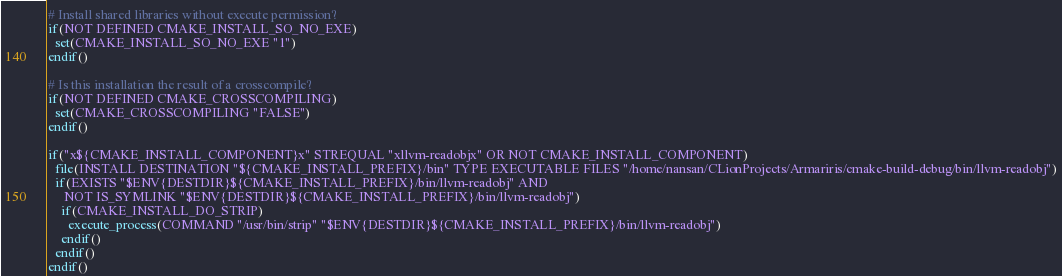Convert code to text. <code><loc_0><loc_0><loc_500><loc_500><_CMake_># Install shared libraries without execute permission?
if(NOT DEFINED CMAKE_INSTALL_SO_NO_EXE)
  set(CMAKE_INSTALL_SO_NO_EXE "1")
endif()

# Is this installation the result of a crosscompile?
if(NOT DEFINED CMAKE_CROSSCOMPILING)
  set(CMAKE_CROSSCOMPILING "FALSE")
endif()

if("x${CMAKE_INSTALL_COMPONENT}x" STREQUAL "xllvm-readobjx" OR NOT CMAKE_INSTALL_COMPONENT)
  file(INSTALL DESTINATION "${CMAKE_INSTALL_PREFIX}/bin" TYPE EXECUTABLE FILES "/home/nansan/CLionProjects/Armariris/cmake-build-debug/bin/llvm-readobj")
  if(EXISTS "$ENV{DESTDIR}${CMAKE_INSTALL_PREFIX}/bin/llvm-readobj" AND
     NOT IS_SYMLINK "$ENV{DESTDIR}${CMAKE_INSTALL_PREFIX}/bin/llvm-readobj")
    if(CMAKE_INSTALL_DO_STRIP)
      execute_process(COMMAND "/usr/bin/strip" "$ENV{DESTDIR}${CMAKE_INSTALL_PREFIX}/bin/llvm-readobj")
    endif()
  endif()
endif()

</code> 